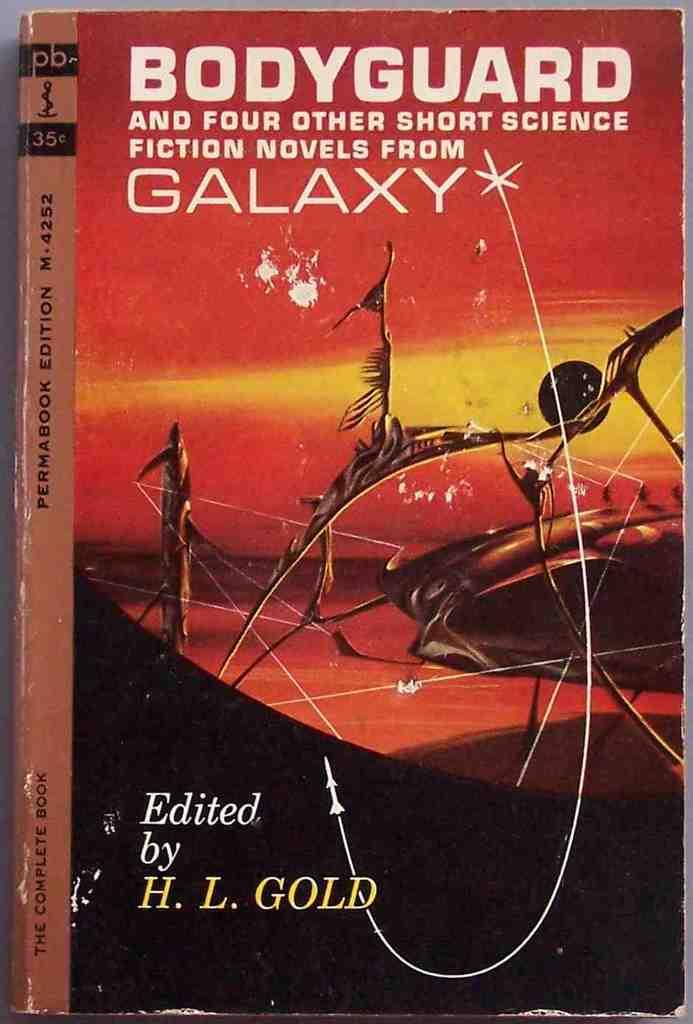How many short novels are included in this book?
Your response must be concise. 5. This is book?
Provide a succinct answer. Yes. 